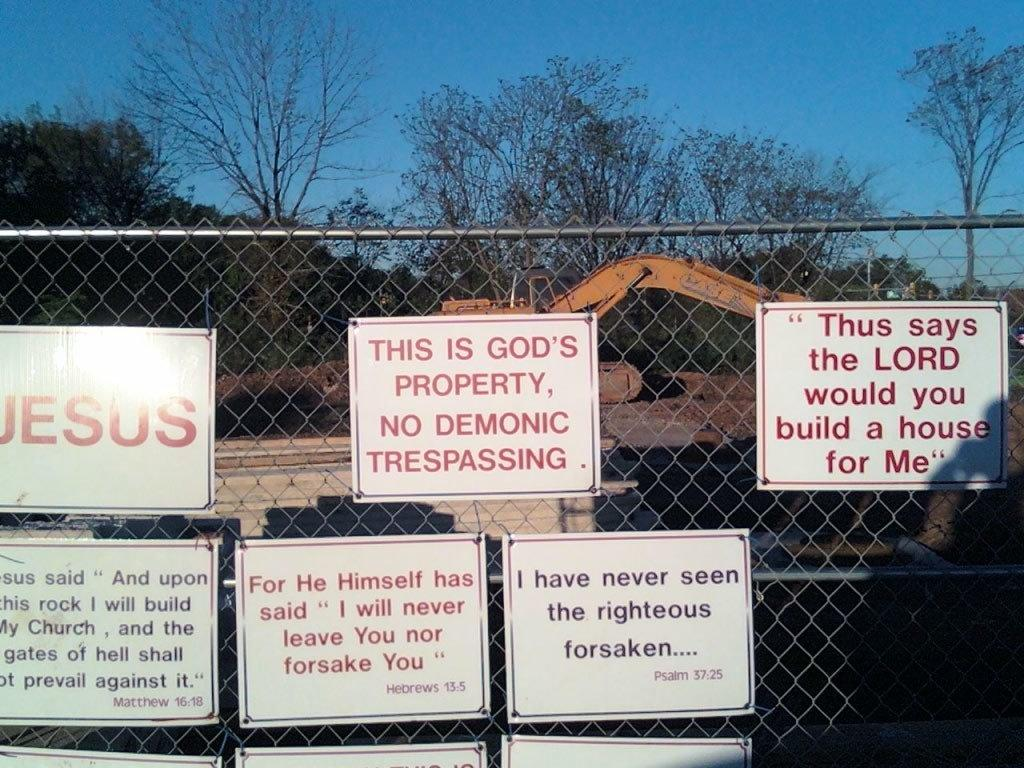<image>
Offer a succinct explanation of the picture presented. A fence with lots of signs about Jesus and religious quotes. 